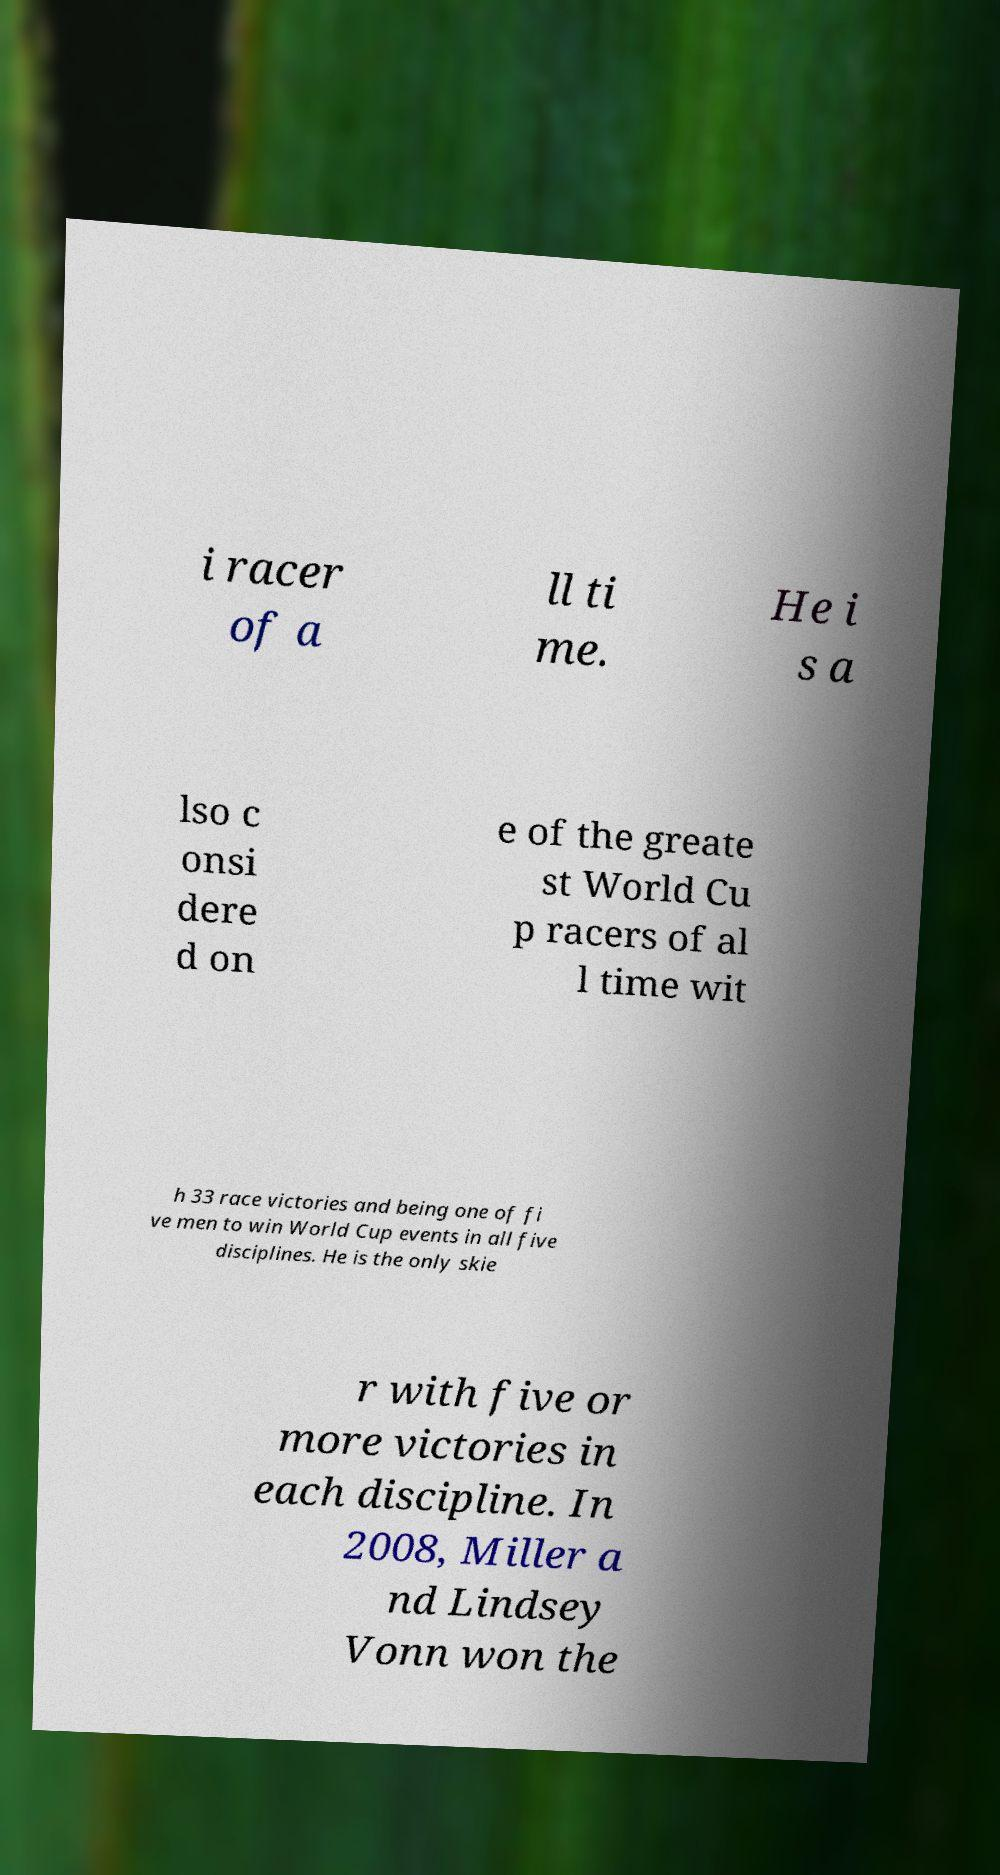Can you read and provide the text displayed in the image?This photo seems to have some interesting text. Can you extract and type it out for me? i racer of a ll ti me. He i s a lso c onsi dere d on e of the greate st World Cu p racers of al l time wit h 33 race victories and being one of fi ve men to win World Cup events in all five disciplines. He is the only skie r with five or more victories in each discipline. In 2008, Miller a nd Lindsey Vonn won the 